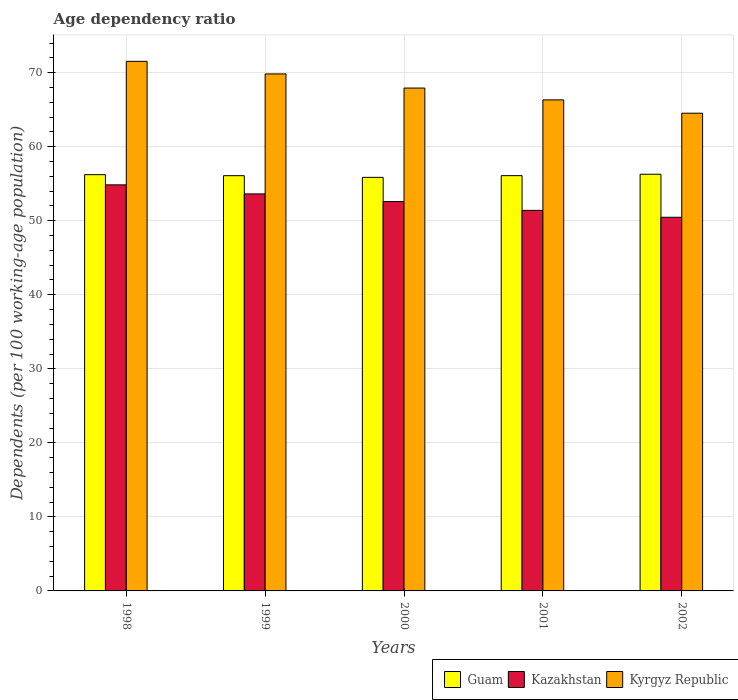How many different coloured bars are there?
Offer a very short reply. 3. How many groups of bars are there?
Your response must be concise. 5. Are the number of bars on each tick of the X-axis equal?
Offer a very short reply. Yes. How many bars are there on the 1st tick from the left?
Make the answer very short. 3. What is the label of the 2nd group of bars from the left?
Provide a short and direct response. 1999. In how many cases, is the number of bars for a given year not equal to the number of legend labels?
Offer a very short reply. 0. What is the age dependency ratio in in Kazakhstan in 2002?
Provide a short and direct response. 50.47. Across all years, what is the maximum age dependency ratio in in Kyrgyz Republic?
Provide a succinct answer. 71.53. Across all years, what is the minimum age dependency ratio in in Kyrgyz Republic?
Give a very brief answer. 64.53. In which year was the age dependency ratio in in Kazakhstan minimum?
Make the answer very short. 2002. What is the total age dependency ratio in in Kazakhstan in the graph?
Keep it short and to the point. 262.94. What is the difference between the age dependency ratio in in Kyrgyz Republic in 2000 and that in 2001?
Make the answer very short. 1.6. What is the difference between the age dependency ratio in in Kazakhstan in 1998 and the age dependency ratio in in Kyrgyz Republic in 2002?
Your answer should be compact. -9.68. What is the average age dependency ratio in in Kyrgyz Republic per year?
Offer a very short reply. 68.03. In the year 2000, what is the difference between the age dependency ratio in in Kyrgyz Republic and age dependency ratio in in Kazakhstan?
Offer a very short reply. 15.34. What is the ratio of the age dependency ratio in in Kyrgyz Republic in 1999 to that in 2002?
Your answer should be very brief. 1.08. Is the difference between the age dependency ratio in in Kyrgyz Republic in 2000 and 2001 greater than the difference between the age dependency ratio in in Kazakhstan in 2000 and 2001?
Ensure brevity in your answer.  Yes. What is the difference between the highest and the second highest age dependency ratio in in Kyrgyz Republic?
Make the answer very short. 1.7. What is the difference between the highest and the lowest age dependency ratio in in Guam?
Your answer should be compact. 0.42. In how many years, is the age dependency ratio in in Kazakhstan greater than the average age dependency ratio in in Kazakhstan taken over all years?
Keep it short and to the point. 2. What does the 1st bar from the left in 2001 represents?
Your answer should be compact. Guam. What does the 2nd bar from the right in 1998 represents?
Offer a terse response. Kazakhstan. Is it the case that in every year, the sum of the age dependency ratio in in Guam and age dependency ratio in in Kazakhstan is greater than the age dependency ratio in in Kyrgyz Republic?
Provide a succinct answer. Yes. Does the graph contain grids?
Your answer should be very brief. Yes. How are the legend labels stacked?
Give a very brief answer. Horizontal. What is the title of the graph?
Provide a short and direct response. Age dependency ratio. Does "Low & middle income" appear as one of the legend labels in the graph?
Your answer should be compact. No. What is the label or title of the Y-axis?
Offer a very short reply. Dependents (per 100 working-age population). What is the Dependents (per 100 working-age population) of Guam in 1998?
Keep it short and to the point. 56.22. What is the Dependents (per 100 working-age population) of Kazakhstan in 1998?
Your answer should be very brief. 54.85. What is the Dependents (per 100 working-age population) of Kyrgyz Republic in 1998?
Give a very brief answer. 71.53. What is the Dependents (per 100 working-age population) in Guam in 1999?
Ensure brevity in your answer.  56.09. What is the Dependents (per 100 working-age population) in Kazakhstan in 1999?
Offer a terse response. 53.63. What is the Dependents (per 100 working-age population) in Kyrgyz Republic in 1999?
Your answer should be compact. 69.83. What is the Dependents (per 100 working-age population) in Guam in 2000?
Provide a short and direct response. 55.86. What is the Dependents (per 100 working-age population) in Kazakhstan in 2000?
Ensure brevity in your answer.  52.59. What is the Dependents (per 100 working-age population) of Kyrgyz Republic in 2000?
Ensure brevity in your answer.  67.92. What is the Dependents (per 100 working-age population) in Guam in 2001?
Ensure brevity in your answer.  56.09. What is the Dependents (per 100 working-age population) of Kazakhstan in 2001?
Your answer should be very brief. 51.4. What is the Dependents (per 100 working-age population) in Kyrgyz Republic in 2001?
Provide a short and direct response. 66.33. What is the Dependents (per 100 working-age population) of Guam in 2002?
Your response must be concise. 56.28. What is the Dependents (per 100 working-age population) in Kazakhstan in 2002?
Offer a terse response. 50.47. What is the Dependents (per 100 working-age population) in Kyrgyz Republic in 2002?
Ensure brevity in your answer.  64.53. Across all years, what is the maximum Dependents (per 100 working-age population) of Guam?
Provide a succinct answer. 56.28. Across all years, what is the maximum Dependents (per 100 working-age population) in Kazakhstan?
Provide a succinct answer. 54.85. Across all years, what is the maximum Dependents (per 100 working-age population) of Kyrgyz Republic?
Offer a terse response. 71.53. Across all years, what is the minimum Dependents (per 100 working-age population) of Guam?
Keep it short and to the point. 55.86. Across all years, what is the minimum Dependents (per 100 working-age population) in Kazakhstan?
Ensure brevity in your answer.  50.47. Across all years, what is the minimum Dependents (per 100 working-age population) in Kyrgyz Republic?
Your answer should be compact. 64.53. What is the total Dependents (per 100 working-age population) in Guam in the graph?
Your response must be concise. 280.54. What is the total Dependents (per 100 working-age population) in Kazakhstan in the graph?
Offer a very short reply. 262.94. What is the total Dependents (per 100 working-age population) of Kyrgyz Republic in the graph?
Offer a very short reply. 340.14. What is the difference between the Dependents (per 100 working-age population) of Guam in 1998 and that in 1999?
Offer a very short reply. 0.14. What is the difference between the Dependents (per 100 working-age population) of Kazakhstan in 1998 and that in 1999?
Keep it short and to the point. 1.22. What is the difference between the Dependents (per 100 working-age population) of Kyrgyz Republic in 1998 and that in 1999?
Provide a succinct answer. 1.7. What is the difference between the Dependents (per 100 working-age population) of Guam in 1998 and that in 2000?
Give a very brief answer. 0.36. What is the difference between the Dependents (per 100 working-age population) of Kazakhstan in 1998 and that in 2000?
Your answer should be very brief. 2.26. What is the difference between the Dependents (per 100 working-age population) in Kyrgyz Republic in 1998 and that in 2000?
Offer a terse response. 3.61. What is the difference between the Dependents (per 100 working-age population) in Guam in 1998 and that in 2001?
Keep it short and to the point. 0.13. What is the difference between the Dependents (per 100 working-age population) in Kazakhstan in 1998 and that in 2001?
Your answer should be very brief. 3.45. What is the difference between the Dependents (per 100 working-age population) in Kyrgyz Republic in 1998 and that in 2001?
Give a very brief answer. 5.2. What is the difference between the Dependents (per 100 working-age population) in Guam in 1998 and that in 2002?
Give a very brief answer. -0.05. What is the difference between the Dependents (per 100 working-age population) in Kazakhstan in 1998 and that in 2002?
Provide a short and direct response. 4.38. What is the difference between the Dependents (per 100 working-age population) of Kyrgyz Republic in 1998 and that in 2002?
Provide a succinct answer. 7. What is the difference between the Dependents (per 100 working-age population) in Guam in 1999 and that in 2000?
Provide a succinct answer. 0.23. What is the difference between the Dependents (per 100 working-age population) in Kazakhstan in 1999 and that in 2000?
Ensure brevity in your answer.  1.04. What is the difference between the Dependents (per 100 working-age population) in Kyrgyz Republic in 1999 and that in 2000?
Make the answer very short. 1.91. What is the difference between the Dependents (per 100 working-age population) in Guam in 1999 and that in 2001?
Make the answer very short. -0.01. What is the difference between the Dependents (per 100 working-age population) in Kazakhstan in 1999 and that in 2001?
Keep it short and to the point. 2.22. What is the difference between the Dependents (per 100 working-age population) in Kyrgyz Republic in 1999 and that in 2001?
Keep it short and to the point. 3.5. What is the difference between the Dependents (per 100 working-age population) in Guam in 1999 and that in 2002?
Give a very brief answer. -0.19. What is the difference between the Dependents (per 100 working-age population) in Kazakhstan in 1999 and that in 2002?
Your answer should be very brief. 3.16. What is the difference between the Dependents (per 100 working-age population) of Kyrgyz Republic in 1999 and that in 2002?
Make the answer very short. 5.31. What is the difference between the Dependents (per 100 working-age population) in Guam in 2000 and that in 2001?
Your response must be concise. -0.23. What is the difference between the Dependents (per 100 working-age population) of Kazakhstan in 2000 and that in 2001?
Your answer should be very brief. 1.18. What is the difference between the Dependents (per 100 working-age population) of Kyrgyz Republic in 2000 and that in 2001?
Provide a succinct answer. 1.6. What is the difference between the Dependents (per 100 working-age population) in Guam in 2000 and that in 2002?
Your answer should be very brief. -0.42. What is the difference between the Dependents (per 100 working-age population) in Kazakhstan in 2000 and that in 2002?
Offer a terse response. 2.12. What is the difference between the Dependents (per 100 working-age population) of Kyrgyz Republic in 2000 and that in 2002?
Offer a terse response. 3.4. What is the difference between the Dependents (per 100 working-age population) in Guam in 2001 and that in 2002?
Offer a terse response. -0.19. What is the difference between the Dependents (per 100 working-age population) in Kazakhstan in 2001 and that in 2002?
Offer a terse response. 0.93. What is the difference between the Dependents (per 100 working-age population) of Kyrgyz Republic in 2001 and that in 2002?
Offer a terse response. 1.8. What is the difference between the Dependents (per 100 working-age population) in Guam in 1998 and the Dependents (per 100 working-age population) in Kazakhstan in 1999?
Make the answer very short. 2.6. What is the difference between the Dependents (per 100 working-age population) in Guam in 1998 and the Dependents (per 100 working-age population) in Kyrgyz Republic in 1999?
Offer a very short reply. -13.61. What is the difference between the Dependents (per 100 working-age population) of Kazakhstan in 1998 and the Dependents (per 100 working-age population) of Kyrgyz Republic in 1999?
Offer a very short reply. -14.98. What is the difference between the Dependents (per 100 working-age population) in Guam in 1998 and the Dependents (per 100 working-age population) in Kazakhstan in 2000?
Keep it short and to the point. 3.64. What is the difference between the Dependents (per 100 working-age population) in Guam in 1998 and the Dependents (per 100 working-age population) in Kyrgyz Republic in 2000?
Offer a terse response. -11.7. What is the difference between the Dependents (per 100 working-age population) in Kazakhstan in 1998 and the Dependents (per 100 working-age population) in Kyrgyz Republic in 2000?
Keep it short and to the point. -13.07. What is the difference between the Dependents (per 100 working-age population) in Guam in 1998 and the Dependents (per 100 working-age population) in Kazakhstan in 2001?
Your answer should be very brief. 4.82. What is the difference between the Dependents (per 100 working-age population) in Guam in 1998 and the Dependents (per 100 working-age population) in Kyrgyz Republic in 2001?
Your response must be concise. -10.1. What is the difference between the Dependents (per 100 working-age population) of Kazakhstan in 1998 and the Dependents (per 100 working-age population) of Kyrgyz Republic in 2001?
Give a very brief answer. -11.48. What is the difference between the Dependents (per 100 working-age population) of Guam in 1998 and the Dependents (per 100 working-age population) of Kazakhstan in 2002?
Make the answer very short. 5.75. What is the difference between the Dependents (per 100 working-age population) of Guam in 1998 and the Dependents (per 100 working-age population) of Kyrgyz Republic in 2002?
Your response must be concise. -8.3. What is the difference between the Dependents (per 100 working-age population) in Kazakhstan in 1998 and the Dependents (per 100 working-age population) in Kyrgyz Republic in 2002?
Provide a succinct answer. -9.68. What is the difference between the Dependents (per 100 working-age population) of Guam in 1999 and the Dependents (per 100 working-age population) of Kazakhstan in 2000?
Your response must be concise. 3.5. What is the difference between the Dependents (per 100 working-age population) of Guam in 1999 and the Dependents (per 100 working-age population) of Kyrgyz Republic in 2000?
Your response must be concise. -11.84. What is the difference between the Dependents (per 100 working-age population) in Kazakhstan in 1999 and the Dependents (per 100 working-age population) in Kyrgyz Republic in 2000?
Give a very brief answer. -14.3. What is the difference between the Dependents (per 100 working-age population) of Guam in 1999 and the Dependents (per 100 working-age population) of Kazakhstan in 2001?
Ensure brevity in your answer.  4.68. What is the difference between the Dependents (per 100 working-age population) of Guam in 1999 and the Dependents (per 100 working-age population) of Kyrgyz Republic in 2001?
Give a very brief answer. -10.24. What is the difference between the Dependents (per 100 working-age population) of Kazakhstan in 1999 and the Dependents (per 100 working-age population) of Kyrgyz Republic in 2001?
Offer a terse response. -12.7. What is the difference between the Dependents (per 100 working-age population) in Guam in 1999 and the Dependents (per 100 working-age population) in Kazakhstan in 2002?
Provide a succinct answer. 5.61. What is the difference between the Dependents (per 100 working-age population) in Guam in 1999 and the Dependents (per 100 working-age population) in Kyrgyz Republic in 2002?
Keep it short and to the point. -8.44. What is the difference between the Dependents (per 100 working-age population) in Kazakhstan in 1999 and the Dependents (per 100 working-age population) in Kyrgyz Republic in 2002?
Your answer should be very brief. -10.9. What is the difference between the Dependents (per 100 working-age population) in Guam in 2000 and the Dependents (per 100 working-age population) in Kazakhstan in 2001?
Keep it short and to the point. 4.46. What is the difference between the Dependents (per 100 working-age population) in Guam in 2000 and the Dependents (per 100 working-age population) in Kyrgyz Republic in 2001?
Your answer should be compact. -10.47. What is the difference between the Dependents (per 100 working-age population) of Kazakhstan in 2000 and the Dependents (per 100 working-age population) of Kyrgyz Republic in 2001?
Ensure brevity in your answer.  -13.74. What is the difference between the Dependents (per 100 working-age population) of Guam in 2000 and the Dependents (per 100 working-age population) of Kazakhstan in 2002?
Ensure brevity in your answer.  5.39. What is the difference between the Dependents (per 100 working-age population) of Guam in 2000 and the Dependents (per 100 working-age population) of Kyrgyz Republic in 2002?
Provide a short and direct response. -8.66. What is the difference between the Dependents (per 100 working-age population) in Kazakhstan in 2000 and the Dependents (per 100 working-age population) in Kyrgyz Republic in 2002?
Your response must be concise. -11.94. What is the difference between the Dependents (per 100 working-age population) in Guam in 2001 and the Dependents (per 100 working-age population) in Kazakhstan in 2002?
Offer a very short reply. 5.62. What is the difference between the Dependents (per 100 working-age population) of Guam in 2001 and the Dependents (per 100 working-age population) of Kyrgyz Republic in 2002?
Your answer should be very brief. -8.43. What is the difference between the Dependents (per 100 working-age population) of Kazakhstan in 2001 and the Dependents (per 100 working-age population) of Kyrgyz Republic in 2002?
Your answer should be very brief. -13.12. What is the average Dependents (per 100 working-age population) of Guam per year?
Provide a short and direct response. 56.11. What is the average Dependents (per 100 working-age population) of Kazakhstan per year?
Provide a succinct answer. 52.59. What is the average Dependents (per 100 working-age population) in Kyrgyz Republic per year?
Offer a terse response. 68.03. In the year 1998, what is the difference between the Dependents (per 100 working-age population) of Guam and Dependents (per 100 working-age population) of Kazakhstan?
Your answer should be compact. 1.37. In the year 1998, what is the difference between the Dependents (per 100 working-age population) of Guam and Dependents (per 100 working-age population) of Kyrgyz Republic?
Offer a very short reply. -15.31. In the year 1998, what is the difference between the Dependents (per 100 working-age population) of Kazakhstan and Dependents (per 100 working-age population) of Kyrgyz Republic?
Keep it short and to the point. -16.68. In the year 1999, what is the difference between the Dependents (per 100 working-age population) of Guam and Dependents (per 100 working-age population) of Kazakhstan?
Offer a very short reply. 2.46. In the year 1999, what is the difference between the Dependents (per 100 working-age population) of Guam and Dependents (per 100 working-age population) of Kyrgyz Republic?
Offer a terse response. -13.74. In the year 1999, what is the difference between the Dependents (per 100 working-age population) of Kazakhstan and Dependents (per 100 working-age population) of Kyrgyz Republic?
Your answer should be compact. -16.2. In the year 2000, what is the difference between the Dependents (per 100 working-age population) of Guam and Dependents (per 100 working-age population) of Kazakhstan?
Give a very brief answer. 3.27. In the year 2000, what is the difference between the Dependents (per 100 working-age population) of Guam and Dependents (per 100 working-age population) of Kyrgyz Republic?
Ensure brevity in your answer.  -12.06. In the year 2000, what is the difference between the Dependents (per 100 working-age population) in Kazakhstan and Dependents (per 100 working-age population) in Kyrgyz Republic?
Provide a succinct answer. -15.34. In the year 2001, what is the difference between the Dependents (per 100 working-age population) in Guam and Dependents (per 100 working-age population) in Kazakhstan?
Make the answer very short. 4.69. In the year 2001, what is the difference between the Dependents (per 100 working-age population) of Guam and Dependents (per 100 working-age population) of Kyrgyz Republic?
Your answer should be compact. -10.24. In the year 2001, what is the difference between the Dependents (per 100 working-age population) in Kazakhstan and Dependents (per 100 working-age population) in Kyrgyz Republic?
Your answer should be very brief. -14.93. In the year 2002, what is the difference between the Dependents (per 100 working-age population) in Guam and Dependents (per 100 working-age population) in Kazakhstan?
Ensure brevity in your answer.  5.81. In the year 2002, what is the difference between the Dependents (per 100 working-age population) in Guam and Dependents (per 100 working-age population) in Kyrgyz Republic?
Your answer should be compact. -8.25. In the year 2002, what is the difference between the Dependents (per 100 working-age population) of Kazakhstan and Dependents (per 100 working-age population) of Kyrgyz Republic?
Your answer should be compact. -14.05. What is the ratio of the Dependents (per 100 working-age population) of Kazakhstan in 1998 to that in 1999?
Ensure brevity in your answer.  1.02. What is the ratio of the Dependents (per 100 working-age population) in Kyrgyz Republic in 1998 to that in 1999?
Offer a very short reply. 1.02. What is the ratio of the Dependents (per 100 working-age population) in Guam in 1998 to that in 2000?
Your answer should be very brief. 1.01. What is the ratio of the Dependents (per 100 working-age population) of Kazakhstan in 1998 to that in 2000?
Your answer should be very brief. 1.04. What is the ratio of the Dependents (per 100 working-age population) of Kyrgyz Republic in 1998 to that in 2000?
Your answer should be compact. 1.05. What is the ratio of the Dependents (per 100 working-age population) in Guam in 1998 to that in 2001?
Provide a short and direct response. 1. What is the ratio of the Dependents (per 100 working-age population) of Kazakhstan in 1998 to that in 2001?
Give a very brief answer. 1.07. What is the ratio of the Dependents (per 100 working-age population) in Kyrgyz Republic in 1998 to that in 2001?
Ensure brevity in your answer.  1.08. What is the ratio of the Dependents (per 100 working-age population) in Kazakhstan in 1998 to that in 2002?
Offer a very short reply. 1.09. What is the ratio of the Dependents (per 100 working-age population) of Kyrgyz Republic in 1998 to that in 2002?
Your answer should be very brief. 1.11. What is the ratio of the Dependents (per 100 working-age population) of Guam in 1999 to that in 2000?
Make the answer very short. 1. What is the ratio of the Dependents (per 100 working-age population) of Kazakhstan in 1999 to that in 2000?
Your answer should be very brief. 1.02. What is the ratio of the Dependents (per 100 working-age population) in Kyrgyz Republic in 1999 to that in 2000?
Provide a short and direct response. 1.03. What is the ratio of the Dependents (per 100 working-age population) in Guam in 1999 to that in 2001?
Provide a succinct answer. 1. What is the ratio of the Dependents (per 100 working-age population) in Kazakhstan in 1999 to that in 2001?
Your answer should be very brief. 1.04. What is the ratio of the Dependents (per 100 working-age population) of Kyrgyz Republic in 1999 to that in 2001?
Your answer should be compact. 1.05. What is the ratio of the Dependents (per 100 working-age population) in Guam in 1999 to that in 2002?
Offer a very short reply. 1. What is the ratio of the Dependents (per 100 working-age population) in Kyrgyz Republic in 1999 to that in 2002?
Your answer should be compact. 1.08. What is the ratio of the Dependents (per 100 working-age population) of Kazakhstan in 2000 to that in 2001?
Keep it short and to the point. 1.02. What is the ratio of the Dependents (per 100 working-age population) in Kyrgyz Republic in 2000 to that in 2001?
Provide a short and direct response. 1.02. What is the ratio of the Dependents (per 100 working-age population) of Kazakhstan in 2000 to that in 2002?
Provide a succinct answer. 1.04. What is the ratio of the Dependents (per 100 working-age population) in Kyrgyz Republic in 2000 to that in 2002?
Provide a short and direct response. 1.05. What is the ratio of the Dependents (per 100 working-age population) in Guam in 2001 to that in 2002?
Provide a succinct answer. 1. What is the ratio of the Dependents (per 100 working-age population) in Kazakhstan in 2001 to that in 2002?
Make the answer very short. 1.02. What is the ratio of the Dependents (per 100 working-age population) of Kyrgyz Republic in 2001 to that in 2002?
Keep it short and to the point. 1.03. What is the difference between the highest and the second highest Dependents (per 100 working-age population) in Guam?
Your response must be concise. 0.05. What is the difference between the highest and the second highest Dependents (per 100 working-age population) of Kazakhstan?
Provide a succinct answer. 1.22. What is the difference between the highest and the second highest Dependents (per 100 working-age population) of Kyrgyz Republic?
Provide a succinct answer. 1.7. What is the difference between the highest and the lowest Dependents (per 100 working-age population) in Guam?
Give a very brief answer. 0.42. What is the difference between the highest and the lowest Dependents (per 100 working-age population) in Kazakhstan?
Keep it short and to the point. 4.38. What is the difference between the highest and the lowest Dependents (per 100 working-age population) in Kyrgyz Republic?
Give a very brief answer. 7. 